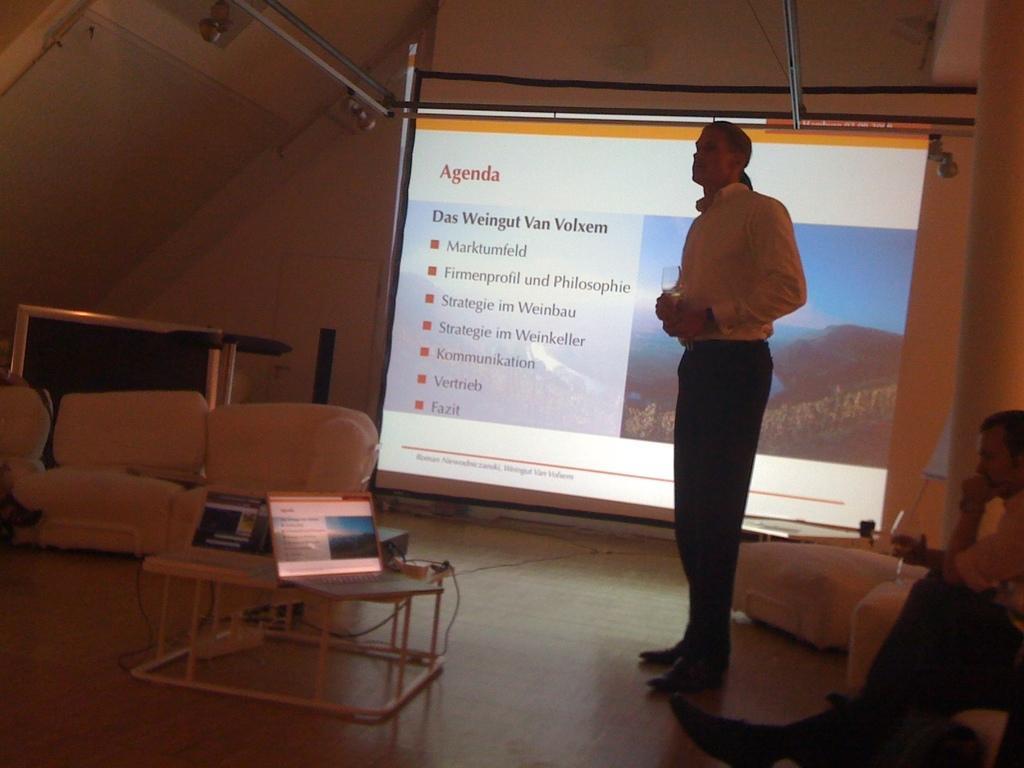Could you give a brief overview of what you see in this image? In the picture we can see a man standing and another man sitting on the chair and we can also find some chairs, sofas, table. On the table we can find a laptop and wires. In the background we can see a screen, wall and stand. 